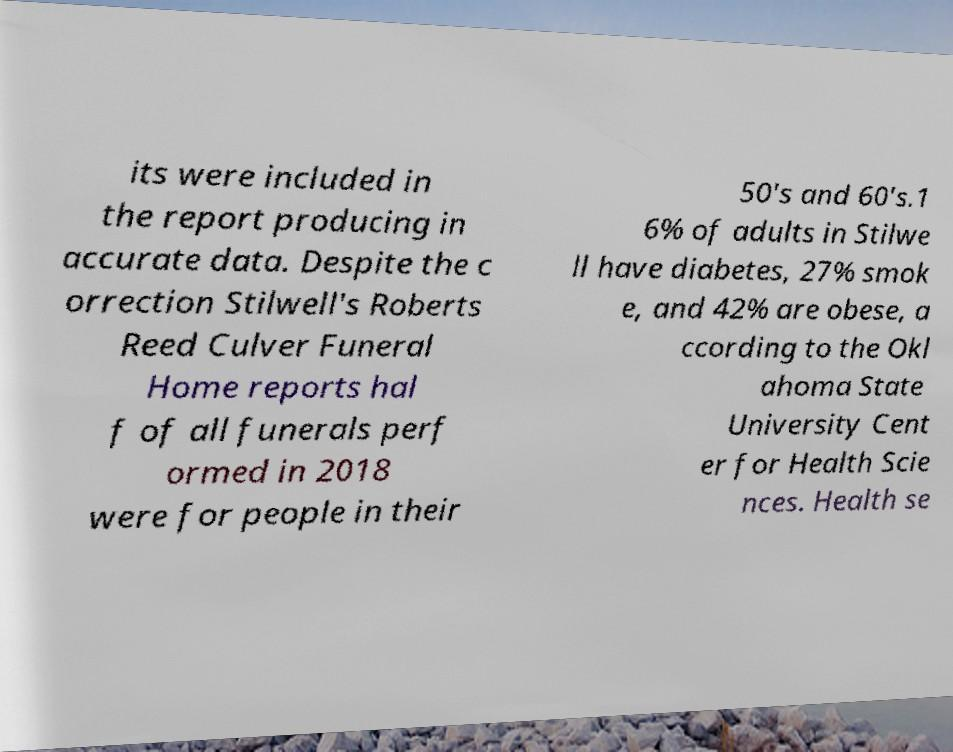What messages or text are displayed in this image? I need them in a readable, typed format. its were included in the report producing in accurate data. Despite the c orrection Stilwell's Roberts Reed Culver Funeral Home reports hal f of all funerals perf ormed in 2018 were for people in their 50's and 60's.1 6% of adults in Stilwe ll have diabetes, 27% smok e, and 42% are obese, a ccording to the Okl ahoma State University Cent er for Health Scie nces. Health se 